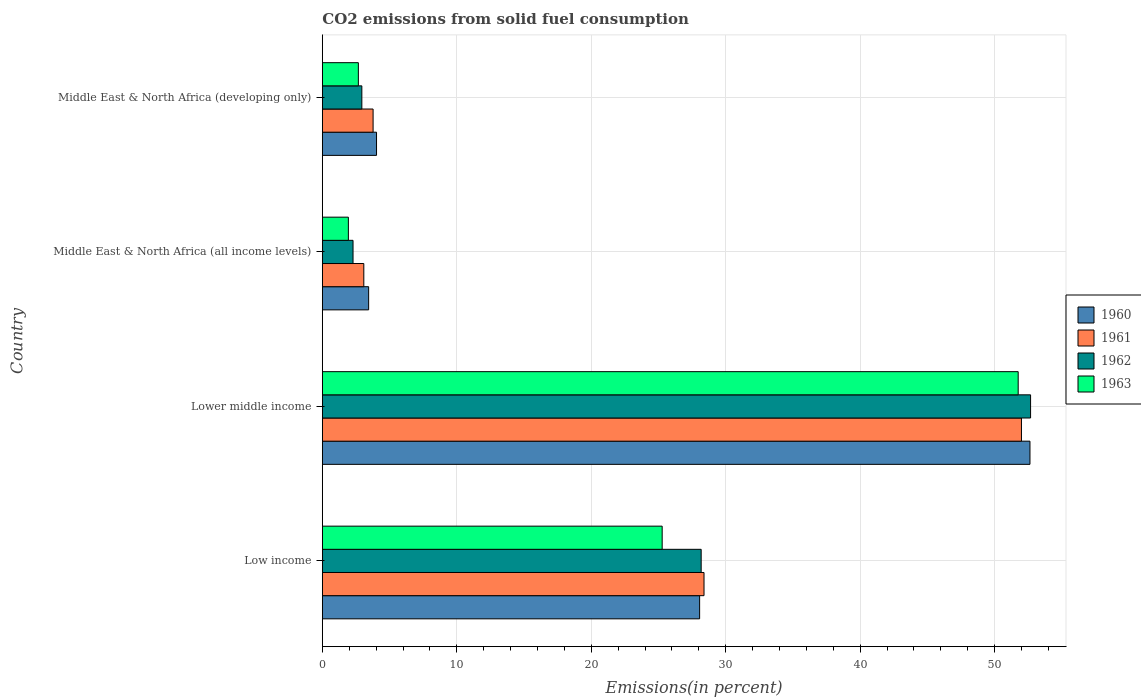How many different coloured bars are there?
Offer a very short reply. 4. Are the number of bars on each tick of the Y-axis equal?
Your answer should be very brief. Yes. What is the label of the 2nd group of bars from the top?
Keep it short and to the point. Middle East & North Africa (all income levels). In how many cases, is the number of bars for a given country not equal to the number of legend labels?
Your answer should be very brief. 0. What is the total CO2 emitted in 1960 in Middle East & North Africa (developing only)?
Give a very brief answer. 4.03. Across all countries, what is the maximum total CO2 emitted in 1960?
Provide a short and direct response. 52.63. Across all countries, what is the minimum total CO2 emitted in 1963?
Offer a terse response. 1.94. In which country was the total CO2 emitted in 1961 maximum?
Your response must be concise. Lower middle income. In which country was the total CO2 emitted in 1961 minimum?
Offer a very short reply. Middle East & North Africa (all income levels). What is the total total CO2 emitted in 1961 in the graph?
Offer a terse response. 87.24. What is the difference between the total CO2 emitted in 1961 in Lower middle income and that in Middle East & North Africa (all income levels)?
Your answer should be compact. 48.91. What is the difference between the total CO2 emitted in 1960 in Low income and the total CO2 emitted in 1962 in Middle East & North Africa (developing only)?
Your answer should be very brief. 25.12. What is the average total CO2 emitted in 1961 per country?
Offer a terse response. 21.81. What is the difference between the total CO2 emitted in 1962 and total CO2 emitted in 1963 in Lower middle income?
Ensure brevity in your answer.  0.92. What is the ratio of the total CO2 emitted in 1961 in Middle East & North Africa (all income levels) to that in Middle East & North Africa (developing only)?
Provide a short and direct response. 0.82. Is the difference between the total CO2 emitted in 1962 in Middle East & North Africa (all income levels) and Middle East & North Africa (developing only) greater than the difference between the total CO2 emitted in 1963 in Middle East & North Africa (all income levels) and Middle East & North Africa (developing only)?
Your answer should be very brief. Yes. What is the difference between the highest and the second highest total CO2 emitted in 1963?
Provide a short and direct response. 26.48. What is the difference between the highest and the lowest total CO2 emitted in 1960?
Provide a short and direct response. 49.18. Is the sum of the total CO2 emitted in 1962 in Middle East & North Africa (all income levels) and Middle East & North Africa (developing only) greater than the maximum total CO2 emitted in 1960 across all countries?
Provide a succinct answer. No. Is it the case that in every country, the sum of the total CO2 emitted in 1962 and total CO2 emitted in 1961 is greater than the sum of total CO2 emitted in 1963 and total CO2 emitted in 1960?
Provide a succinct answer. Yes. Is it the case that in every country, the sum of the total CO2 emitted in 1962 and total CO2 emitted in 1961 is greater than the total CO2 emitted in 1960?
Your response must be concise. Yes. Are all the bars in the graph horizontal?
Offer a very short reply. Yes. How many countries are there in the graph?
Your answer should be very brief. 4. Are the values on the major ticks of X-axis written in scientific E-notation?
Offer a terse response. No. Does the graph contain any zero values?
Provide a succinct answer. No. Where does the legend appear in the graph?
Offer a very short reply. Center right. What is the title of the graph?
Provide a succinct answer. CO2 emissions from solid fuel consumption. Does "2011" appear as one of the legend labels in the graph?
Your answer should be very brief. No. What is the label or title of the X-axis?
Provide a succinct answer. Emissions(in percent). What is the Emissions(in percent) of 1960 in Low income?
Your response must be concise. 28.06. What is the Emissions(in percent) in 1961 in Low income?
Ensure brevity in your answer.  28.39. What is the Emissions(in percent) of 1962 in Low income?
Offer a very short reply. 28.17. What is the Emissions(in percent) in 1963 in Low income?
Keep it short and to the point. 25.27. What is the Emissions(in percent) in 1960 in Lower middle income?
Keep it short and to the point. 52.63. What is the Emissions(in percent) of 1961 in Lower middle income?
Make the answer very short. 51.99. What is the Emissions(in percent) of 1962 in Lower middle income?
Keep it short and to the point. 52.67. What is the Emissions(in percent) in 1963 in Lower middle income?
Provide a short and direct response. 51.75. What is the Emissions(in percent) of 1960 in Middle East & North Africa (all income levels)?
Offer a terse response. 3.44. What is the Emissions(in percent) of 1961 in Middle East & North Africa (all income levels)?
Ensure brevity in your answer.  3.09. What is the Emissions(in percent) in 1962 in Middle East & North Africa (all income levels)?
Provide a succinct answer. 2.28. What is the Emissions(in percent) in 1963 in Middle East & North Africa (all income levels)?
Your response must be concise. 1.94. What is the Emissions(in percent) of 1960 in Middle East & North Africa (developing only)?
Offer a terse response. 4.03. What is the Emissions(in percent) in 1961 in Middle East & North Africa (developing only)?
Ensure brevity in your answer.  3.78. What is the Emissions(in percent) in 1962 in Middle East & North Africa (developing only)?
Offer a terse response. 2.94. What is the Emissions(in percent) in 1963 in Middle East & North Africa (developing only)?
Ensure brevity in your answer.  2.68. Across all countries, what is the maximum Emissions(in percent) in 1960?
Keep it short and to the point. 52.63. Across all countries, what is the maximum Emissions(in percent) in 1961?
Your response must be concise. 51.99. Across all countries, what is the maximum Emissions(in percent) in 1962?
Offer a terse response. 52.67. Across all countries, what is the maximum Emissions(in percent) in 1963?
Make the answer very short. 51.75. Across all countries, what is the minimum Emissions(in percent) of 1960?
Your answer should be very brief. 3.44. Across all countries, what is the minimum Emissions(in percent) in 1961?
Provide a succinct answer. 3.09. Across all countries, what is the minimum Emissions(in percent) of 1962?
Ensure brevity in your answer.  2.28. Across all countries, what is the minimum Emissions(in percent) of 1963?
Give a very brief answer. 1.94. What is the total Emissions(in percent) in 1960 in the graph?
Offer a terse response. 88.16. What is the total Emissions(in percent) in 1961 in the graph?
Your answer should be compact. 87.24. What is the total Emissions(in percent) in 1962 in the graph?
Keep it short and to the point. 86.07. What is the total Emissions(in percent) in 1963 in the graph?
Your response must be concise. 81.64. What is the difference between the Emissions(in percent) of 1960 in Low income and that in Lower middle income?
Your response must be concise. -24.57. What is the difference between the Emissions(in percent) in 1961 in Low income and that in Lower middle income?
Your response must be concise. -23.61. What is the difference between the Emissions(in percent) in 1962 in Low income and that in Lower middle income?
Your response must be concise. -24.5. What is the difference between the Emissions(in percent) in 1963 in Low income and that in Lower middle income?
Make the answer very short. -26.48. What is the difference between the Emissions(in percent) in 1960 in Low income and that in Middle East & North Africa (all income levels)?
Your response must be concise. 24.62. What is the difference between the Emissions(in percent) in 1961 in Low income and that in Middle East & North Africa (all income levels)?
Offer a terse response. 25.3. What is the difference between the Emissions(in percent) of 1962 in Low income and that in Middle East & North Africa (all income levels)?
Make the answer very short. 25.89. What is the difference between the Emissions(in percent) in 1963 in Low income and that in Middle East & North Africa (all income levels)?
Offer a terse response. 23.34. What is the difference between the Emissions(in percent) in 1960 in Low income and that in Middle East & North Africa (developing only)?
Provide a short and direct response. 24.03. What is the difference between the Emissions(in percent) in 1961 in Low income and that in Middle East & North Africa (developing only)?
Make the answer very short. 24.61. What is the difference between the Emissions(in percent) of 1962 in Low income and that in Middle East & North Africa (developing only)?
Offer a very short reply. 25.24. What is the difference between the Emissions(in percent) in 1963 in Low income and that in Middle East & North Africa (developing only)?
Your answer should be very brief. 22.6. What is the difference between the Emissions(in percent) in 1960 in Lower middle income and that in Middle East & North Africa (all income levels)?
Keep it short and to the point. 49.18. What is the difference between the Emissions(in percent) in 1961 in Lower middle income and that in Middle East & North Africa (all income levels)?
Provide a short and direct response. 48.91. What is the difference between the Emissions(in percent) in 1962 in Lower middle income and that in Middle East & North Africa (all income levels)?
Keep it short and to the point. 50.39. What is the difference between the Emissions(in percent) in 1963 in Lower middle income and that in Middle East & North Africa (all income levels)?
Your answer should be compact. 49.81. What is the difference between the Emissions(in percent) of 1960 in Lower middle income and that in Middle East & North Africa (developing only)?
Your answer should be compact. 48.6. What is the difference between the Emissions(in percent) in 1961 in Lower middle income and that in Middle East & North Africa (developing only)?
Give a very brief answer. 48.22. What is the difference between the Emissions(in percent) of 1962 in Lower middle income and that in Middle East & North Africa (developing only)?
Provide a short and direct response. 49.73. What is the difference between the Emissions(in percent) of 1963 in Lower middle income and that in Middle East & North Africa (developing only)?
Provide a succinct answer. 49.07. What is the difference between the Emissions(in percent) of 1960 in Middle East & North Africa (all income levels) and that in Middle East & North Africa (developing only)?
Ensure brevity in your answer.  -0.59. What is the difference between the Emissions(in percent) in 1961 in Middle East & North Africa (all income levels) and that in Middle East & North Africa (developing only)?
Ensure brevity in your answer.  -0.69. What is the difference between the Emissions(in percent) of 1962 in Middle East & North Africa (all income levels) and that in Middle East & North Africa (developing only)?
Your response must be concise. -0.65. What is the difference between the Emissions(in percent) in 1963 in Middle East & North Africa (all income levels) and that in Middle East & North Africa (developing only)?
Your response must be concise. -0.74. What is the difference between the Emissions(in percent) in 1960 in Low income and the Emissions(in percent) in 1961 in Lower middle income?
Offer a terse response. -23.93. What is the difference between the Emissions(in percent) in 1960 in Low income and the Emissions(in percent) in 1962 in Lower middle income?
Your response must be concise. -24.61. What is the difference between the Emissions(in percent) in 1960 in Low income and the Emissions(in percent) in 1963 in Lower middle income?
Your answer should be compact. -23.69. What is the difference between the Emissions(in percent) in 1961 in Low income and the Emissions(in percent) in 1962 in Lower middle income?
Give a very brief answer. -24.29. What is the difference between the Emissions(in percent) of 1961 in Low income and the Emissions(in percent) of 1963 in Lower middle income?
Keep it short and to the point. -23.36. What is the difference between the Emissions(in percent) in 1962 in Low income and the Emissions(in percent) in 1963 in Lower middle income?
Provide a short and direct response. -23.58. What is the difference between the Emissions(in percent) of 1960 in Low income and the Emissions(in percent) of 1961 in Middle East & North Africa (all income levels)?
Give a very brief answer. 24.97. What is the difference between the Emissions(in percent) in 1960 in Low income and the Emissions(in percent) in 1962 in Middle East & North Africa (all income levels)?
Provide a short and direct response. 25.78. What is the difference between the Emissions(in percent) of 1960 in Low income and the Emissions(in percent) of 1963 in Middle East & North Africa (all income levels)?
Offer a very short reply. 26.12. What is the difference between the Emissions(in percent) of 1961 in Low income and the Emissions(in percent) of 1962 in Middle East & North Africa (all income levels)?
Your answer should be compact. 26.1. What is the difference between the Emissions(in percent) of 1961 in Low income and the Emissions(in percent) of 1963 in Middle East & North Africa (all income levels)?
Provide a short and direct response. 26.45. What is the difference between the Emissions(in percent) of 1962 in Low income and the Emissions(in percent) of 1963 in Middle East & North Africa (all income levels)?
Your answer should be compact. 26.24. What is the difference between the Emissions(in percent) in 1960 in Low income and the Emissions(in percent) in 1961 in Middle East & North Africa (developing only)?
Offer a terse response. 24.28. What is the difference between the Emissions(in percent) of 1960 in Low income and the Emissions(in percent) of 1962 in Middle East & North Africa (developing only)?
Your answer should be very brief. 25.12. What is the difference between the Emissions(in percent) of 1960 in Low income and the Emissions(in percent) of 1963 in Middle East & North Africa (developing only)?
Provide a succinct answer. 25.38. What is the difference between the Emissions(in percent) in 1961 in Low income and the Emissions(in percent) in 1962 in Middle East & North Africa (developing only)?
Make the answer very short. 25.45. What is the difference between the Emissions(in percent) of 1961 in Low income and the Emissions(in percent) of 1963 in Middle East & North Africa (developing only)?
Make the answer very short. 25.71. What is the difference between the Emissions(in percent) of 1962 in Low income and the Emissions(in percent) of 1963 in Middle East & North Africa (developing only)?
Provide a succinct answer. 25.49. What is the difference between the Emissions(in percent) of 1960 in Lower middle income and the Emissions(in percent) of 1961 in Middle East & North Africa (all income levels)?
Make the answer very short. 49.54. What is the difference between the Emissions(in percent) of 1960 in Lower middle income and the Emissions(in percent) of 1962 in Middle East & North Africa (all income levels)?
Offer a terse response. 50.34. What is the difference between the Emissions(in percent) of 1960 in Lower middle income and the Emissions(in percent) of 1963 in Middle East & North Africa (all income levels)?
Provide a short and direct response. 50.69. What is the difference between the Emissions(in percent) of 1961 in Lower middle income and the Emissions(in percent) of 1962 in Middle East & North Africa (all income levels)?
Your answer should be very brief. 49.71. What is the difference between the Emissions(in percent) in 1961 in Lower middle income and the Emissions(in percent) in 1963 in Middle East & North Africa (all income levels)?
Your response must be concise. 50.06. What is the difference between the Emissions(in percent) of 1962 in Lower middle income and the Emissions(in percent) of 1963 in Middle East & North Africa (all income levels)?
Provide a short and direct response. 50.74. What is the difference between the Emissions(in percent) of 1960 in Lower middle income and the Emissions(in percent) of 1961 in Middle East & North Africa (developing only)?
Keep it short and to the point. 48.85. What is the difference between the Emissions(in percent) in 1960 in Lower middle income and the Emissions(in percent) in 1962 in Middle East & North Africa (developing only)?
Offer a terse response. 49.69. What is the difference between the Emissions(in percent) of 1960 in Lower middle income and the Emissions(in percent) of 1963 in Middle East & North Africa (developing only)?
Offer a very short reply. 49.95. What is the difference between the Emissions(in percent) of 1961 in Lower middle income and the Emissions(in percent) of 1962 in Middle East & North Africa (developing only)?
Offer a terse response. 49.06. What is the difference between the Emissions(in percent) in 1961 in Lower middle income and the Emissions(in percent) in 1963 in Middle East & North Africa (developing only)?
Your answer should be compact. 49.32. What is the difference between the Emissions(in percent) in 1962 in Lower middle income and the Emissions(in percent) in 1963 in Middle East & North Africa (developing only)?
Offer a terse response. 49.99. What is the difference between the Emissions(in percent) in 1960 in Middle East & North Africa (all income levels) and the Emissions(in percent) in 1961 in Middle East & North Africa (developing only)?
Keep it short and to the point. -0.33. What is the difference between the Emissions(in percent) in 1960 in Middle East & North Africa (all income levels) and the Emissions(in percent) in 1962 in Middle East & North Africa (developing only)?
Offer a very short reply. 0.51. What is the difference between the Emissions(in percent) in 1960 in Middle East & North Africa (all income levels) and the Emissions(in percent) in 1963 in Middle East & North Africa (developing only)?
Provide a short and direct response. 0.76. What is the difference between the Emissions(in percent) of 1961 in Middle East & North Africa (all income levels) and the Emissions(in percent) of 1962 in Middle East & North Africa (developing only)?
Provide a short and direct response. 0.15. What is the difference between the Emissions(in percent) of 1961 in Middle East & North Africa (all income levels) and the Emissions(in percent) of 1963 in Middle East & North Africa (developing only)?
Make the answer very short. 0.41. What is the difference between the Emissions(in percent) of 1962 in Middle East & North Africa (all income levels) and the Emissions(in percent) of 1963 in Middle East & North Africa (developing only)?
Make the answer very short. -0.4. What is the average Emissions(in percent) in 1960 per country?
Ensure brevity in your answer.  22.04. What is the average Emissions(in percent) in 1961 per country?
Ensure brevity in your answer.  21.81. What is the average Emissions(in percent) in 1962 per country?
Your answer should be very brief. 21.52. What is the average Emissions(in percent) in 1963 per country?
Keep it short and to the point. 20.41. What is the difference between the Emissions(in percent) in 1960 and Emissions(in percent) in 1961 in Low income?
Provide a short and direct response. -0.33. What is the difference between the Emissions(in percent) in 1960 and Emissions(in percent) in 1962 in Low income?
Provide a short and direct response. -0.11. What is the difference between the Emissions(in percent) in 1960 and Emissions(in percent) in 1963 in Low income?
Your answer should be very brief. 2.79. What is the difference between the Emissions(in percent) in 1961 and Emissions(in percent) in 1962 in Low income?
Give a very brief answer. 0.21. What is the difference between the Emissions(in percent) in 1961 and Emissions(in percent) in 1963 in Low income?
Offer a terse response. 3.11. What is the difference between the Emissions(in percent) of 1962 and Emissions(in percent) of 1963 in Low income?
Keep it short and to the point. 2.9. What is the difference between the Emissions(in percent) in 1960 and Emissions(in percent) in 1961 in Lower middle income?
Your answer should be compact. 0.63. What is the difference between the Emissions(in percent) in 1960 and Emissions(in percent) in 1962 in Lower middle income?
Offer a terse response. -0.05. What is the difference between the Emissions(in percent) of 1960 and Emissions(in percent) of 1963 in Lower middle income?
Ensure brevity in your answer.  0.88. What is the difference between the Emissions(in percent) in 1961 and Emissions(in percent) in 1962 in Lower middle income?
Your answer should be compact. -0.68. What is the difference between the Emissions(in percent) in 1961 and Emissions(in percent) in 1963 in Lower middle income?
Keep it short and to the point. 0.24. What is the difference between the Emissions(in percent) in 1962 and Emissions(in percent) in 1963 in Lower middle income?
Give a very brief answer. 0.92. What is the difference between the Emissions(in percent) of 1960 and Emissions(in percent) of 1961 in Middle East & North Africa (all income levels)?
Give a very brief answer. 0.36. What is the difference between the Emissions(in percent) of 1960 and Emissions(in percent) of 1962 in Middle East & North Africa (all income levels)?
Make the answer very short. 1.16. What is the difference between the Emissions(in percent) of 1960 and Emissions(in percent) of 1963 in Middle East & North Africa (all income levels)?
Provide a succinct answer. 1.51. What is the difference between the Emissions(in percent) in 1961 and Emissions(in percent) in 1962 in Middle East & North Africa (all income levels)?
Provide a succinct answer. 0.8. What is the difference between the Emissions(in percent) in 1961 and Emissions(in percent) in 1963 in Middle East & North Africa (all income levels)?
Ensure brevity in your answer.  1.15. What is the difference between the Emissions(in percent) in 1962 and Emissions(in percent) in 1963 in Middle East & North Africa (all income levels)?
Offer a very short reply. 0.35. What is the difference between the Emissions(in percent) of 1960 and Emissions(in percent) of 1961 in Middle East & North Africa (developing only)?
Ensure brevity in your answer.  0.25. What is the difference between the Emissions(in percent) of 1960 and Emissions(in percent) of 1962 in Middle East & North Africa (developing only)?
Your answer should be very brief. 1.09. What is the difference between the Emissions(in percent) in 1960 and Emissions(in percent) in 1963 in Middle East & North Africa (developing only)?
Provide a succinct answer. 1.35. What is the difference between the Emissions(in percent) in 1961 and Emissions(in percent) in 1962 in Middle East & North Africa (developing only)?
Offer a very short reply. 0.84. What is the difference between the Emissions(in percent) of 1961 and Emissions(in percent) of 1963 in Middle East & North Africa (developing only)?
Keep it short and to the point. 1.1. What is the difference between the Emissions(in percent) in 1962 and Emissions(in percent) in 1963 in Middle East & North Africa (developing only)?
Give a very brief answer. 0.26. What is the ratio of the Emissions(in percent) of 1960 in Low income to that in Lower middle income?
Ensure brevity in your answer.  0.53. What is the ratio of the Emissions(in percent) in 1961 in Low income to that in Lower middle income?
Ensure brevity in your answer.  0.55. What is the ratio of the Emissions(in percent) of 1962 in Low income to that in Lower middle income?
Make the answer very short. 0.53. What is the ratio of the Emissions(in percent) in 1963 in Low income to that in Lower middle income?
Keep it short and to the point. 0.49. What is the ratio of the Emissions(in percent) in 1960 in Low income to that in Middle East & North Africa (all income levels)?
Your answer should be very brief. 8.15. What is the ratio of the Emissions(in percent) of 1961 in Low income to that in Middle East & North Africa (all income levels)?
Ensure brevity in your answer.  9.2. What is the ratio of the Emissions(in percent) of 1962 in Low income to that in Middle East & North Africa (all income levels)?
Your answer should be very brief. 12.34. What is the ratio of the Emissions(in percent) of 1963 in Low income to that in Middle East & North Africa (all income levels)?
Provide a succinct answer. 13.04. What is the ratio of the Emissions(in percent) of 1960 in Low income to that in Middle East & North Africa (developing only)?
Your response must be concise. 6.96. What is the ratio of the Emissions(in percent) of 1961 in Low income to that in Middle East & North Africa (developing only)?
Ensure brevity in your answer.  7.52. What is the ratio of the Emissions(in percent) of 1962 in Low income to that in Middle East & North Africa (developing only)?
Give a very brief answer. 9.59. What is the ratio of the Emissions(in percent) of 1963 in Low income to that in Middle East & North Africa (developing only)?
Offer a terse response. 9.43. What is the ratio of the Emissions(in percent) of 1960 in Lower middle income to that in Middle East & North Africa (all income levels)?
Your answer should be compact. 15.28. What is the ratio of the Emissions(in percent) in 1961 in Lower middle income to that in Middle East & North Africa (all income levels)?
Give a very brief answer. 16.85. What is the ratio of the Emissions(in percent) of 1962 in Lower middle income to that in Middle East & North Africa (all income levels)?
Offer a very short reply. 23.07. What is the ratio of the Emissions(in percent) of 1963 in Lower middle income to that in Middle East & North Africa (all income levels)?
Keep it short and to the point. 26.71. What is the ratio of the Emissions(in percent) of 1960 in Lower middle income to that in Middle East & North Africa (developing only)?
Offer a terse response. 13.06. What is the ratio of the Emissions(in percent) in 1961 in Lower middle income to that in Middle East & North Africa (developing only)?
Keep it short and to the point. 13.77. What is the ratio of the Emissions(in percent) of 1962 in Lower middle income to that in Middle East & North Africa (developing only)?
Give a very brief answer. 17.93. What is the ratio of the Emissions(in percent) in 1963 in Lower middle income to that in Middle East & North Africa (developing only)?
Your answer should be compact. 19.31. What is the ratio of the Emissions(in percent) in 1960 in Middle East & North Africa (all income levels) to that in Middle East & North Africa (developing only)?
Ensure brevity in your answer.  0.85. What is the ratio of the Emissions(in percent) of 1961 in Middle East & North Africa (all income levels) to that in Middle East & North Africa (developing only)?
Make the answer very short. 0.82. What is the ratio of the Emissions(in percent) of 1962 in Middle East & North Africa (all income levels) to that in Middle East & North Africa (developing only)?
Provide a short and direct response. 0.78. What is the ratio of the Emissions(in percent) in 1963 in Middle East & North Africa (all income levels) to that in Middle East & North Africa (developing only)?
Offer a very short reply. 0.72. What is the difference between the highest and the second highest Emissions(in percent) in 1960?
Give a very brief answer. 24.57. What is the difference between the highest and the second highest Emissions(in percent) of 1961?
Provide a succinct answer. 23.61. What is the difference between the highest and the second highest Emissions(in percent) in 1962?
Keep it short and to the point. 24.5. What is the difference between the highest and the second highest Emissions(in percent) of 1963?
Give a very brief answer. 26.48. What is the difference between the highest and the lowest Emissions(in percent) of 1960?
Make the answer very short. 49.18. What is the difference between the highest and the lowest Emissions(in percent) in 1961?
Ensure brevity in your answer.  48.91. What is the difference between the highest and the lowest Emissions(in percent) of 1962?
Your answer should be very brief. 50.39. What is the difference between the highest and the lowest Emissions(in percent) in 1963?
Your response must be concise. 49.81. 